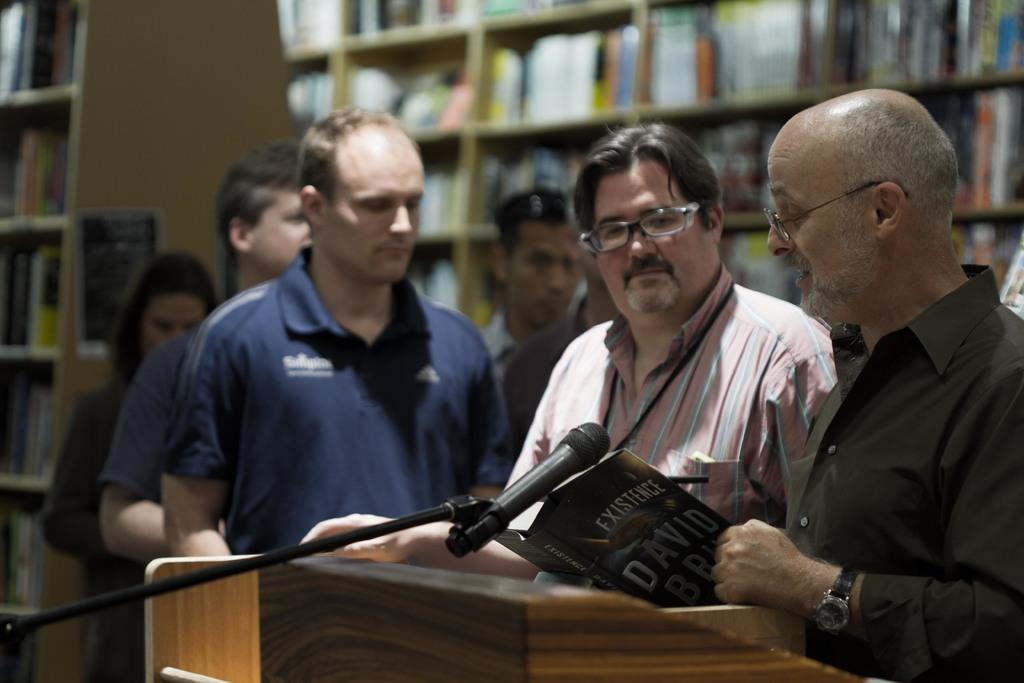<image>
Create a compact narrative representing the image presented. A man in a black shirt stands behind a podium holding a book called Existence. 